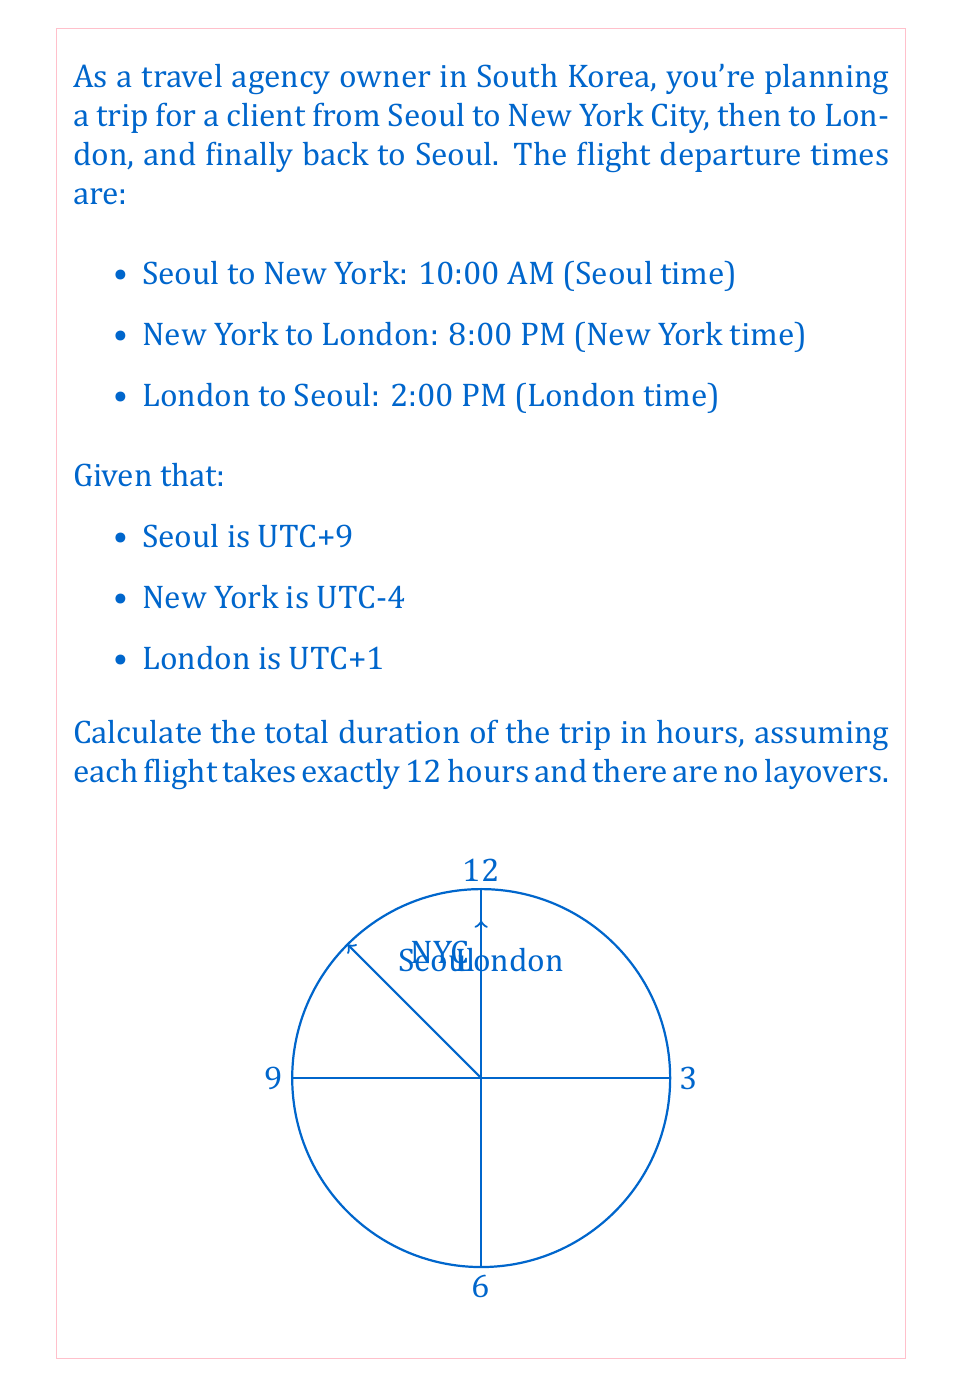Solve this math problem. Let's solve this problem step by step:

1) First, let's convert all times to UTC:

   Seoul departure: 10:00 AM UTC+9 = 01:00 AM UTC
   New York departure: 8:00 PM UTC-4 = 00:00 AM UTC (next day)
   London departure: 2:00 PM UTC+1 = 13:00 PM UTC

2) Now, let's calculate the time difference between each flight:

   Seoul to New York: 
   $$00:00 - 01:00 = 23 \text{ hours}$$

   New York to London:
   $$13:00 - 00:00 = 13 \text{ hours}$$

   London to Seoul:
   $$01:00 - 13:00 = 12 \text{ hours}$$ (adding 24 hours as it's the next day)

3) Sum up the time differences:
   $$23 + 13 + 12 = 48 \text{ hours}$$

4) However, each flight takes exactly 12 hours. So the actual flight time is:
   $$3 \times 12 = 36 \text{ hours}$$

5) The difference between the total time and the flight time is the time zone changes:
   $$48 - 36 = 12 \text{ hours}$$

Therefore, the total duration of the trip is 48 hours, or exactly 2 days.
Answer: 48 hours 